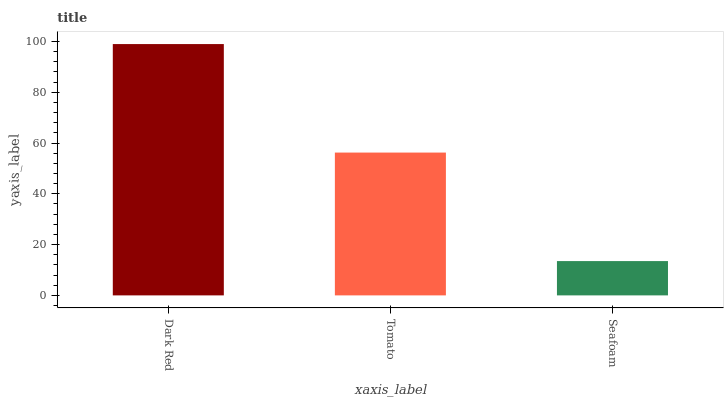Is Tomato the minimum?
Answer yes or no. No. Is Tomato the maximum?
Answer yes or no. No. Is Dark Red greater than Tomato?
Answer yes or no. Yes. Is Tomato less than Dark Red?
Answer yes or no. Yes. Is Tomato greater than Dark Red?
Answer yes or no. No. Is Dark Red less than Tomato?
Answer yes or no. No. Is Tomato the high median?
Answer yes or no. Yes. Is Tomato the low median?
Answer yes or no. Yes. Is Dark Red the high median?
Answer yes or no. No. Is Seafoam the low median?
Answer yes or no. No. 